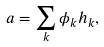<formula> <loc_0><loc_0><loc_500><loc_500>a = \sum _ { k } \phi _ { k } h _ { k } ,</formula> 